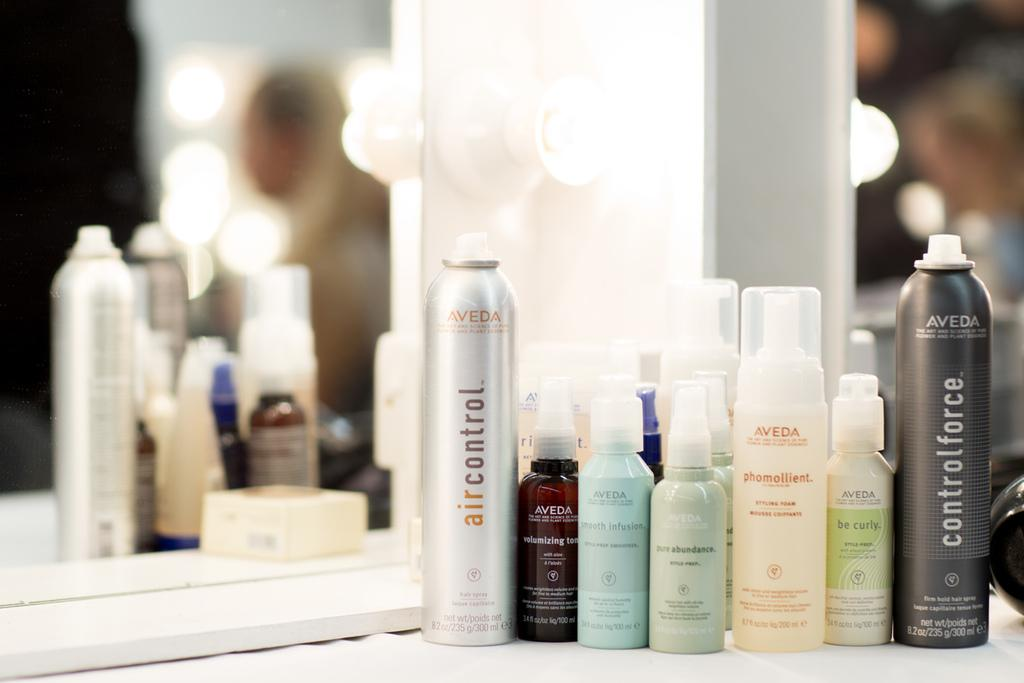What objects are present in large quantities in the image? There are many bottles in the image. Where are the bottles located? The bottles are placed on a table. What other object can be seen in the image? There is a mirror in the image. What type of pest can be seen crawling on the bottles in the image? There are no pests visible in the image; it only shows bottles on a table and a mirror. 